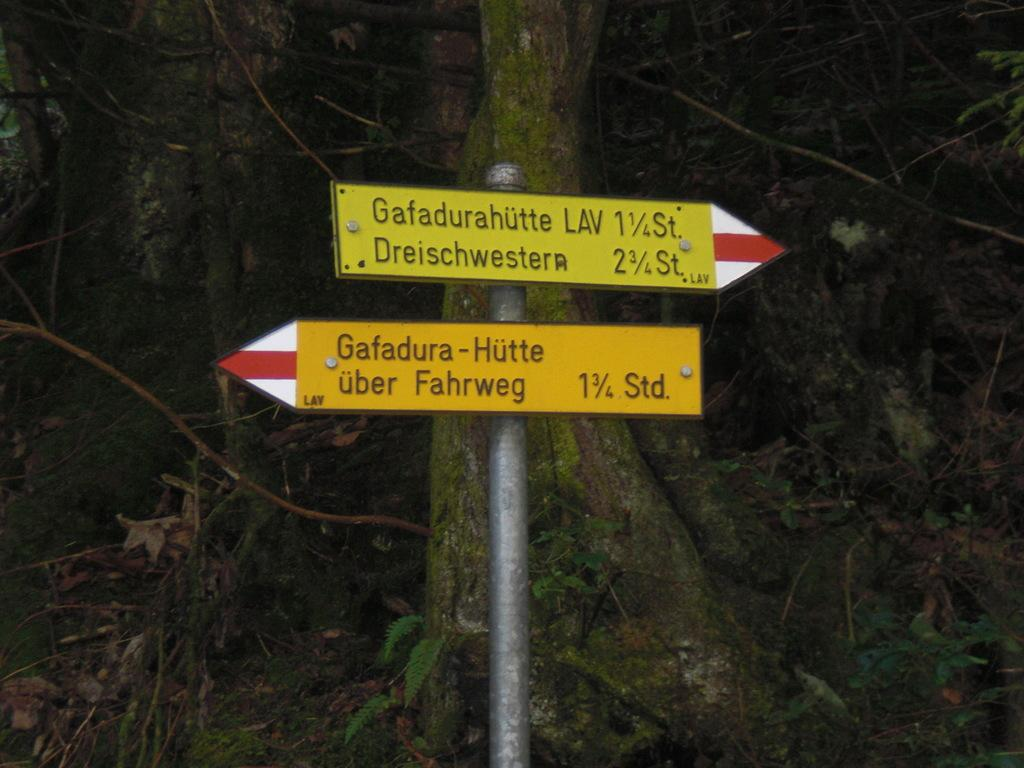What is the main object in the image? There is a pole in the image. What is attached to the pole? There are two boards on the pole. What can be read on the boards? There is text on the boards. What type of natural elements can be seen in the image? Leaves are visible in the image. What other objects are present in the image? Wooden sticks are present in the image. What type of record can be seen spinning on the pole in the image? There is no record present in the image; it features a pole with two boards and text. Can you tell me how many berries are hanging from the wooden sticks in the image? There are no berries present in the image; it features a pole with two boards, text, leaves, and wooden sticks. 